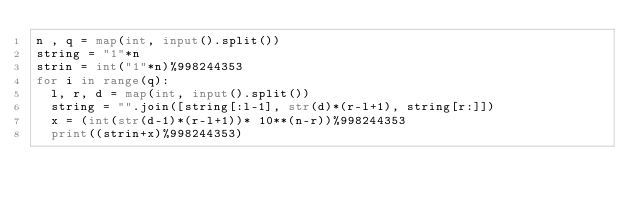Convert code to text. <code><loc_0><loc_0><loc_500><loc_500><_Python_>n , q = map(int, input().split())
string = "1"*n
strin = int("1"*n)%998244353
for i in range(q):
  l, r, d = map(int, input().split())
  string = "".join([string[:l-1], str(d)*(r-l+1), string[r:]])
  x = (int(str(d-1)*(r-l+1))* 10**(n-r))%998244353
  print((strin+x)%998244353)</code> 